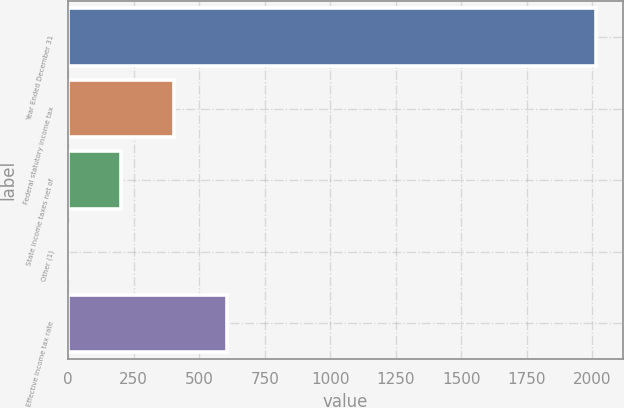Convert chart. <chart><loc_0><loc_0><loc_500><loc_500><bar_chart><fcel>Year Ended December 31<fcel>Federal statutory income tax<fcel>State income taxes net of<fcel>Other (1)<fcel>Effective income tax rate<nl><fcel>2016<fcel>403.6<fcel>202.05<fcel>0.5<fcel>605.15<nl></chart> 